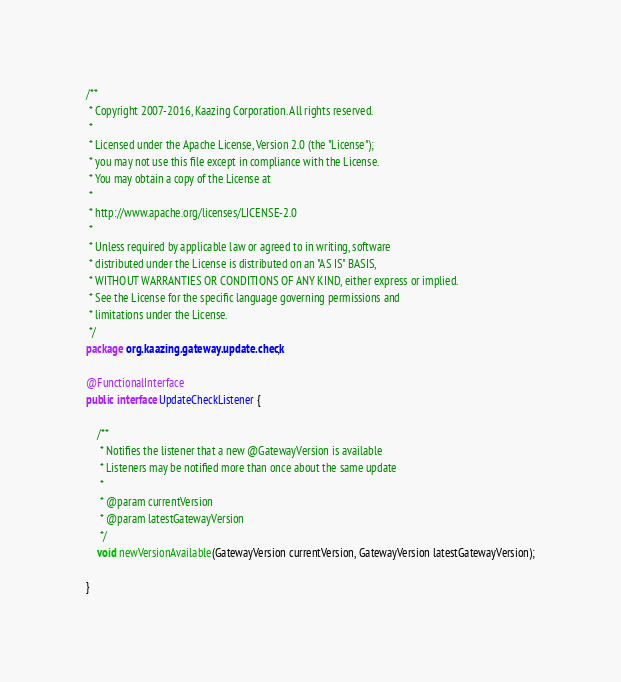<code> <loc_0><loc_0><loc_500><loc_500><_Java_>/**
 * Copyright 2007-2016, Kaazing Corporation. All rights reserved.
 *
 * Licensed under the Apache License, Version 2.0 (the "License");
 * you may not use this file except in compliance with the License.
 * You may obtain a copy of the License at
 *
 * http://www.apache.org/licenses/LICENSE-2.0
 *
 * Unless required by applicable law or agreed to in writing, software
 * distributed under the License is distributed on an "AS IS" BASIS,
 * WITHOUT WARRANTIES OR CONDITIONS OF ANY KIND, either express or implied.
 * See the License for the specific language governing permissions and
 * limitations under the License.
 */
package org.kaazing.gateway.update.check;

@FunctionalInterface
public interface UpdateCheckListener {

    /**
     * Notifies the listener that a new @GatewayVersion is available
     * Listeners may be notified more than once about the same update
     *
     * @param currentVersion
     * @param latestGatewayVersion
     */
    void newVersionAvailable(GatewayVersion currentVersion, GatewayVersion latestGatewayVersion);

}
</code> 